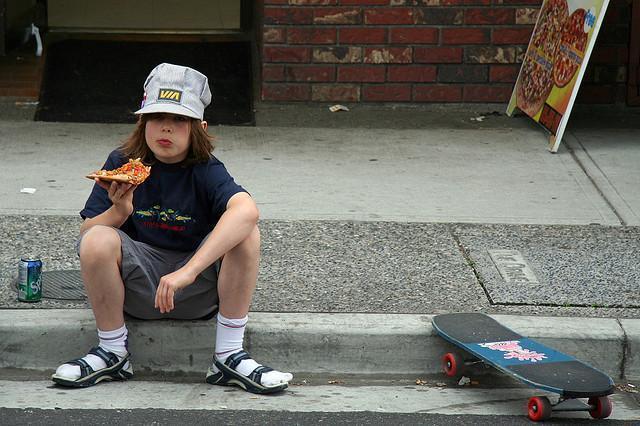How many people in the picture?
Give a very brief answer. 1. How many people are there?
Give a very brief answer. 1. 